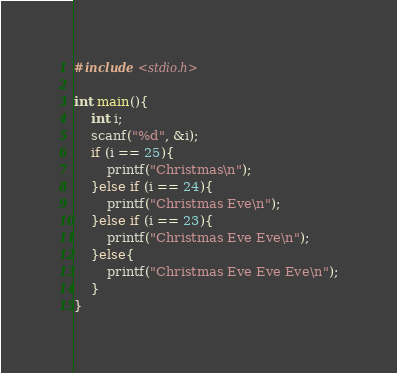<code> <loc_0><loc_0><loc_500><loc_500><_C_>#include <stdio.h>

int main(){
	int i;
	scanf("%d", &i);
	if (i == 25){
		printf("Christmas\n");
	}else if (i == 24){
		printf("Christmas Eve\n");
	}else if (i == 23){
		printf("Christmas Eve Eve\n");
	}else{
		printf("Christmas Eve Eve Eve\n");
	}
}</code> 